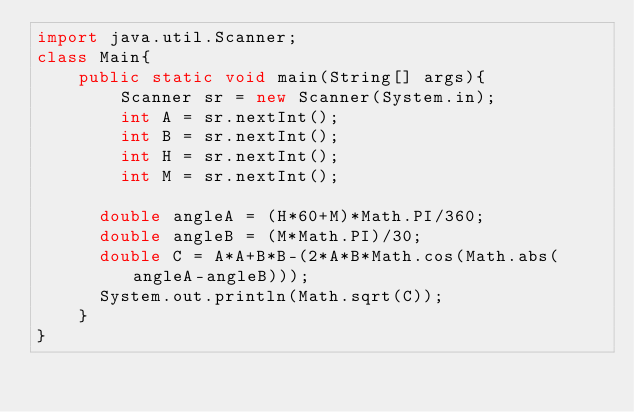Convert code to text. <code><loc_0><loc_0><loc_500><loc_500><_Java_>import java.util.Scanner;
class Main{
	public static void main(String[] args){
    	Scanner sr = new Scanner(System.in);
      	int A = sr.nextInt();
      	int B = sr.nextInt();
      	int H = sr.nextInt();
      	int M = sr.nextInt();
      	
      double angleA = (H*60+M)*Math.PI/360;    
      double angleB = (M*Math.PI)/30;
      double C = A*A+B*B-(2*A*B*Math.cos(Math.abs(angleA-angleB)));
      System.out.println(Math.sqrt(C));
    }
} </code> 